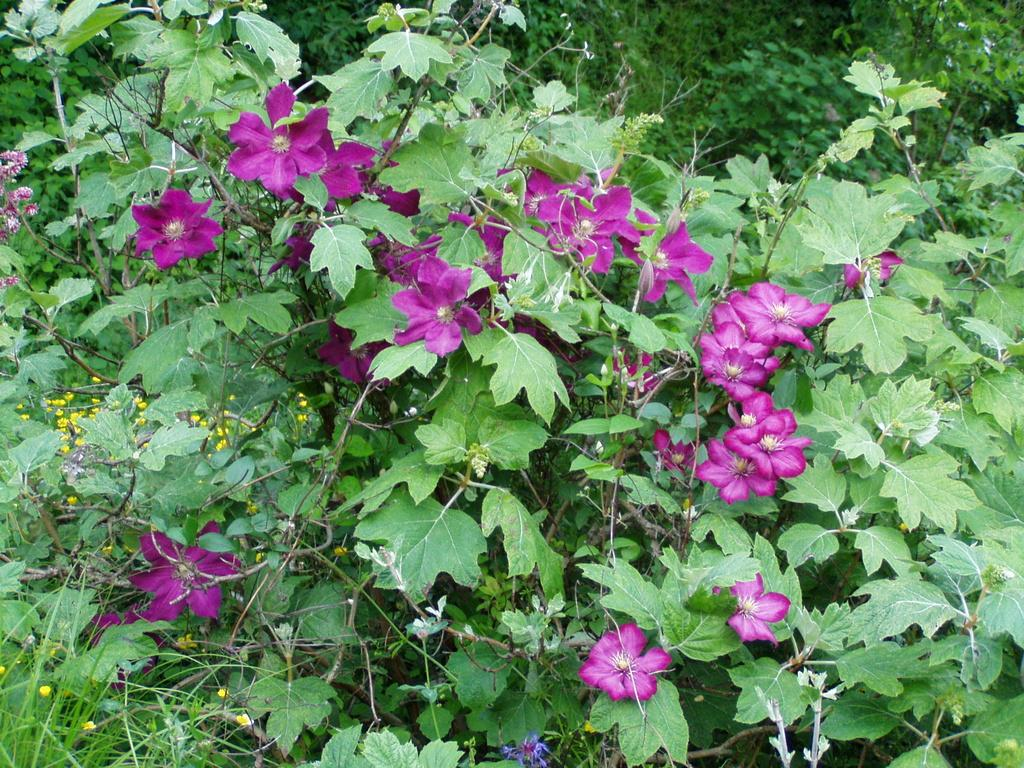What type of living organisms can be seen in the image? Plants and flowers are visible in the image. Can you describe the flowers in the image? The flowers in the image are part of the plants. Is there a kettle visible in the image? No, there is no kettle present in the image. Are there any cobwebs visible in the image? No, there are no cobwebs present in the image. 